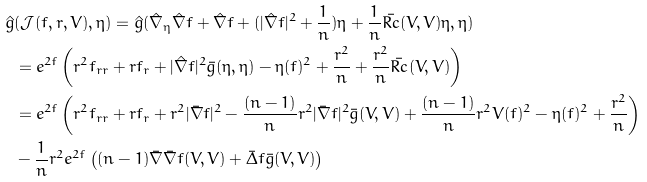Convert formula to latex. <formula><loc_0><loc_0><loc_500><loc_500>\hat { g } & ( \mathcal { J } ( f , r , V ) , \eta ) = \hat { g } ( \hat { \nabla } _ { \eta } \hat { \nabla } f + \hat { \nabla } f + ( | \hat { \nabla } f | ^ { 2 } + \frac { 1 } { n } ) \eta + \frac { 1 } { n } \bar { R c } ( V , V ) \eta , \eta ) \\ & = e ^ { 2 f } \left ( r ^ { 2 } f _ { r r } + r f _ { r } + | \hat { \nabla } f | ^ { 2 } \bar { g } ( \eta , \eta ) - \eta ( f ) ^ { 2 } + \frac { r ^ { 2 } } { n } + \frac { r ^ { 2 } } { n } \bar { R c } ( V , V ) \right ) \\ & = e ^ { 2 f } \left ( r ^ { 2 } f _ { r r } + r f _ { r } + r ^ { 2 } | \bar { \nabla } f | ^ { 2 } - \frac { ( n - 1 ) } { n } r ^ { 2 } | \bar { \nabla } f | ^ { 2 } \bar { g } ( V , V ) + \frac { ( n - 1 ) } { n } r ^ { 2 } V ( f ) ^ { 2 } - \eta ( f ) ^ { 2 } + \frac { r ^ { 2 } } { n } \right ) \\ & - \frac { 1 } { n } r ^ { 2 } e ^ { 2 f } \left ( ( n - 1 ) \bar { \nabla } \bar { \nabla } f ( V , V ) + \bar { \Delta } f \bar { g } ( V , V ) \right )</formula> 